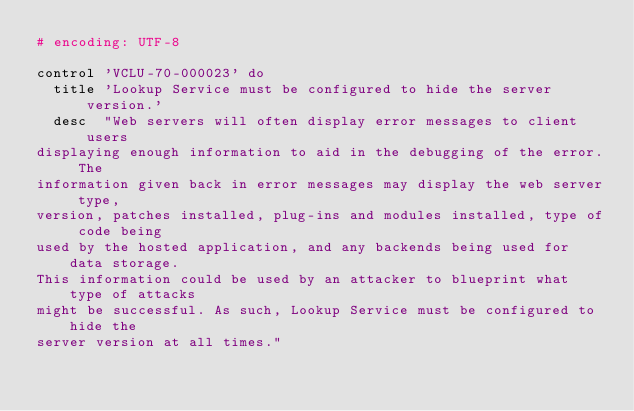Convert code to text. <code><loc_0><loc_0><loc_500><loc_500><_Ruby_># encoding: UTF-8

control 'VCLU-70-000023' do
  title 'Lookup Service must be configured to hide the server version.'
  desc  "Web servers will often display error messages to client users
displaying enough information to aid in the debugging of the error. The
information given back in error messages may display the web server type,
version, patches installed, plug-ins and modules installed, type of code being
used by the hosted application, and any backends being used for data storage.
This information could be used by an attacker to blueprint what type of attacks
might be successful. As such, Lookup Service must be configured to hide the
server version at all times."</code> 